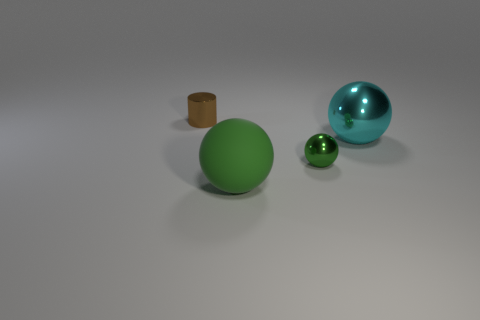Add 1 tiny things. How many objects exist? 5 Subtract all balls. How many objects are left? 1 Add 3 small green rubber spheres. How many small green rubber spheres exist? 3 Subtract 0 brown spheres. How many objects are left? 4 Subtract all green objects. Subtract all large green spheres. How many objects are left? 1 Add 3 brown objects. How many brown objects are left? 4 